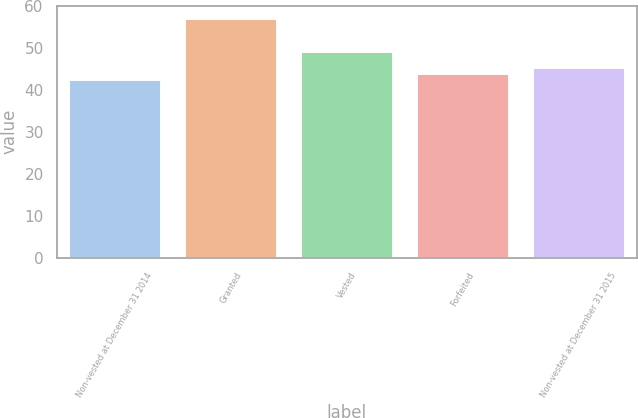Convert chart to OTSL. <chart><loc_0><loc_0><loc_500><loc_500><bar_chart><fcel>Non-vested at December 31 2014<fcel>Granted<fcel>Vested<fcel>Forfeited<fcel>Non-vested at December 31 2015<nl><fcel>42.58<fcel>57.22<fcel>49.34<fcel>44.04<fcel>45.5<nl></chart> 